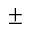Convert formula to latex. <formula><loc_0><loc_0><loc_500><loc_500>\pm</formula> 